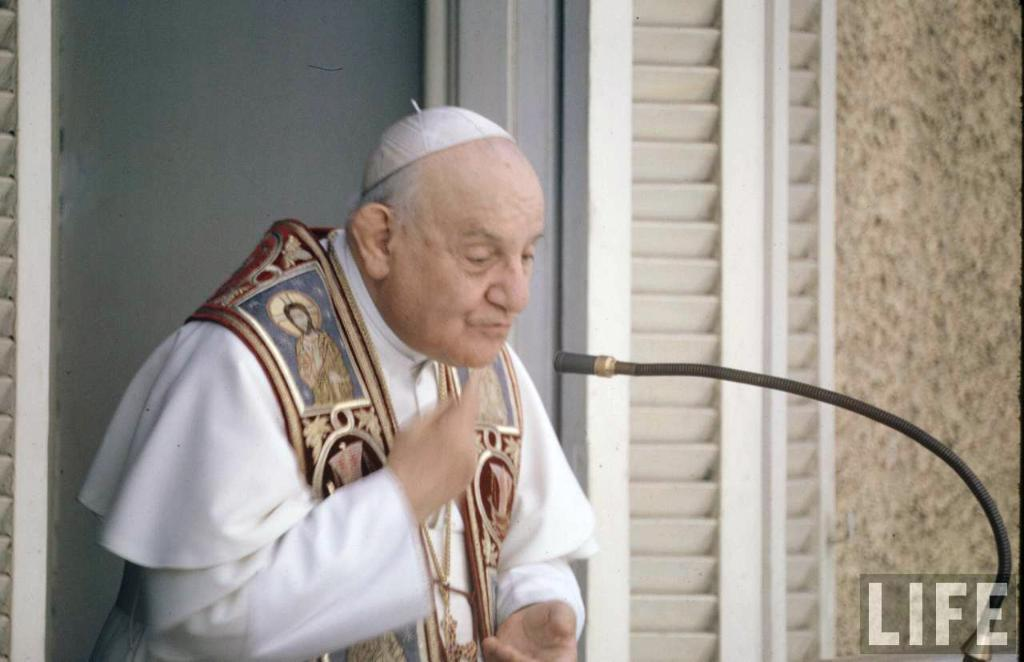What is the main subject of the image? There is an old man standing in the image. What object can be seen near the old man? There is a black color microphone in the image. What is visible in the background of the image? There is a wall in the background of the image. What type of pie is being served on the tub in the image? There is no tub or pie present in the image. What type of machine is being used by the old man in the image? There is no machine visible in the image; the old man is simply standing with a microphone. 